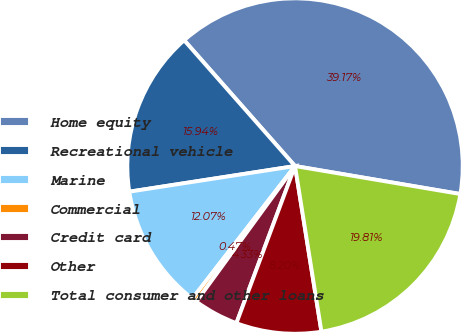Convert chart to OTSL. <chart><loc_0><loc_0><loc_500><loc_500><pie_chart><fcel>Home equity<fcel>Recreational vehicle<fcel>Marine<fcel>Commercial<fcel>Credit card<fcel>Other<fcel>Total consumer and other loans<nl><fcel>39.16%<fcel>15.94%<fcel>12.07%<fcel>0.47%<fcel>4.33%<fcel>8.2%<fcel>19.81%<nl></chart> 